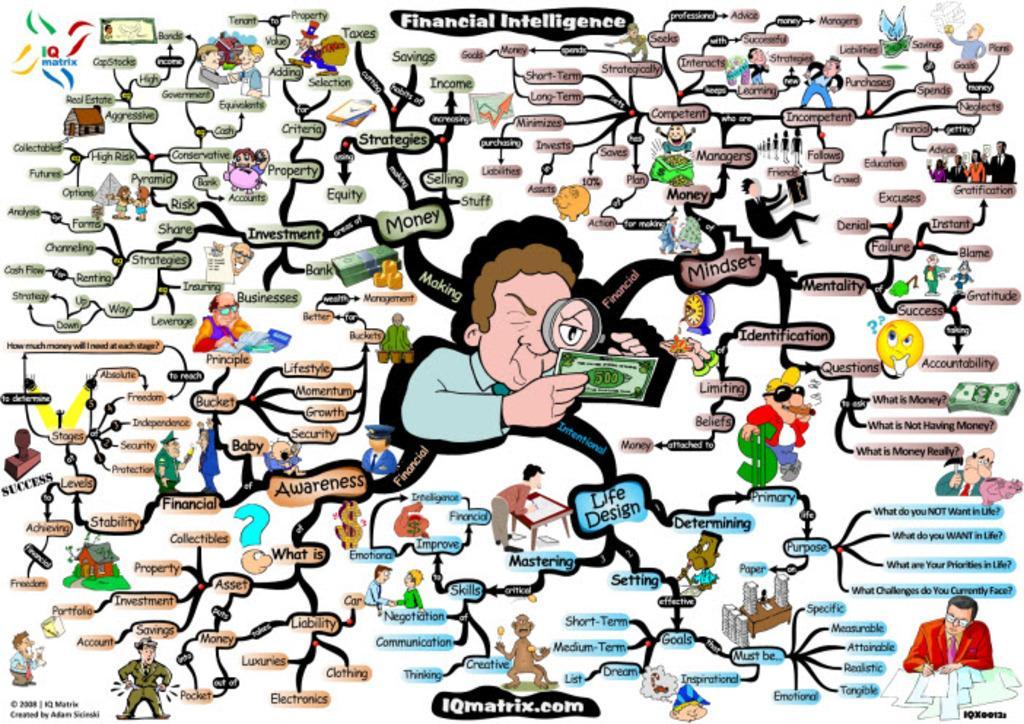Could you give a brief overview of what you see in this image? In this image there is a financial intelligence flow chart with some cartoon images of persons and labels. 